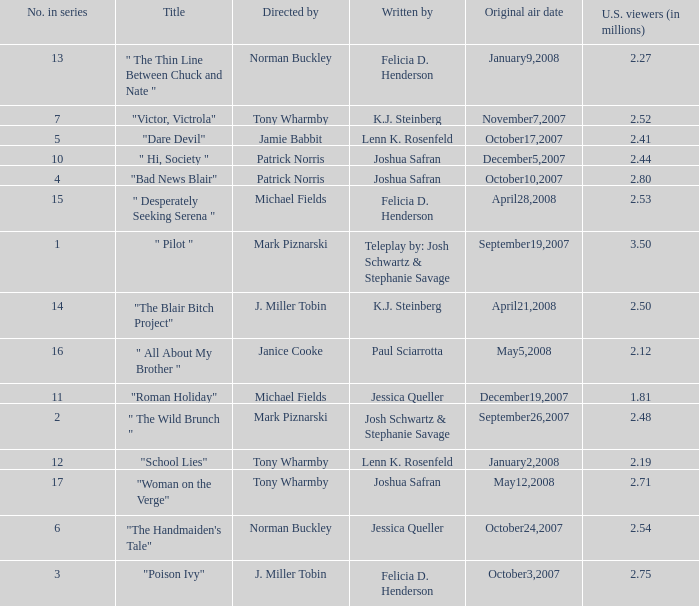How many directed by have 2.80 as u.s. viewers  (in millions)? 1.0. 